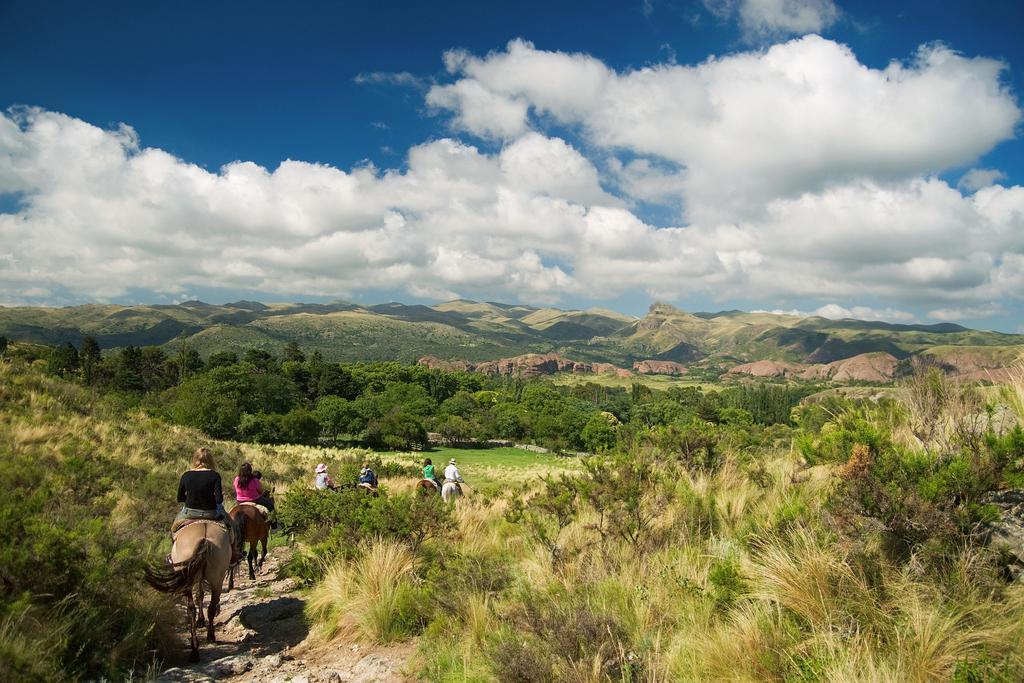Describe this image in one or two sentences. At the bottom of the picture, we see six people riding six horses. We even see grass. There are many trees and hills in the background. At the top of the picture, we see the sky, which is blue in color and we even see clouds. 